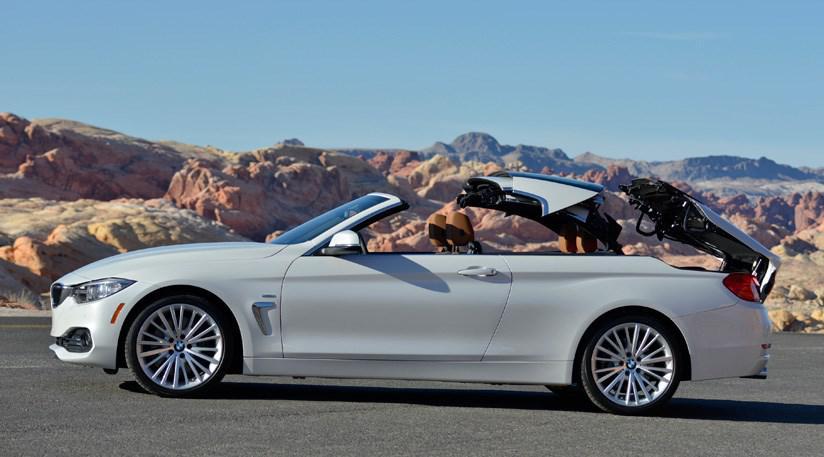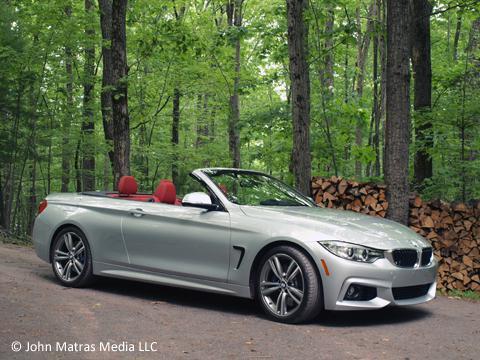The first image is the image on the left, the second image is the image on the right. Evaluate the accuracy of this statement regarding the images: "Two sports cars with chrome wheels and dual exhaust are parked at an angle so that the rear license plate is visible.". Is it true? Answer yes or no. No. The first image is the image on the left, the second image is the image on the right. Evaluate the accuracy of this statement regarding the images: "An image shows a convertible with top down angled rightward, with tailights facing the camera.". Is it true? Answer yes or no. No. 